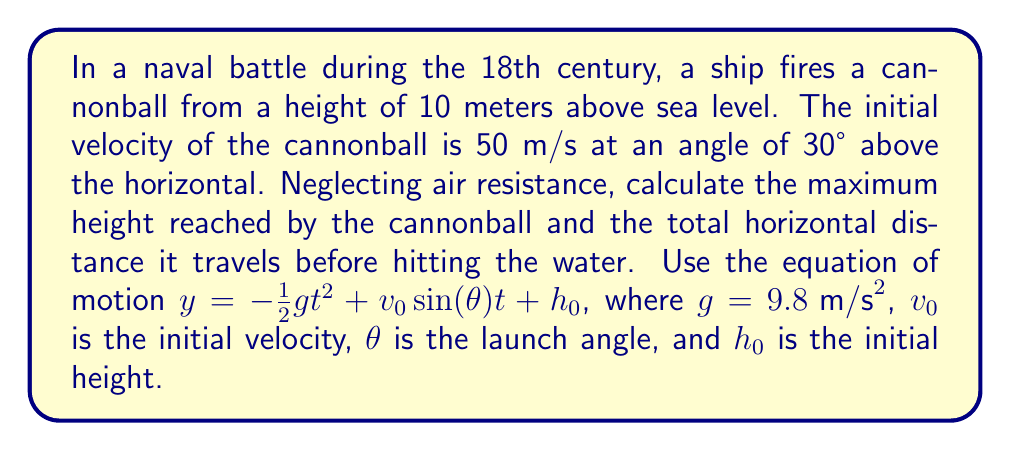Can you solve this math problem? Let's approach this step-by-step:

1) First, let's identify our known values:
   $v_0 = 50 \text{ m/s}$
   $\theta = 30°$
   $h_0 = 10 \text{ m}$
   $g = 9.8 \text{ m/s}^2$

2) To find the maximum height, we need to find when the vertical velocity is zero. The vertical component of velocity is given by:
   $v_y = v_0\sin(\theta) - gt$

3) Set this to zero and solve for t:
   $0 = 50\sin(30°) - 9.8t$
   $0 = 25 - 9.8t$
   $t = \frac{25}{9.8} \approx 2.55 \text{ s}$

4) Now we can plug this time into our equation of motion to find the maximum height:
   $y_{max} = -\frac{1}{2}(9.8)(2.55)^2 + 50\sin(30°)(2.55) + 10$
   $y_{max} \approx 41.8 \text{ m}$

5) To find the total horizontal distance, we need to find when y = 0 (sea level). We can use the quadratic formula to solve the equation:
   $0 = -\frac{1}{2}gt^2 + v_0\sin(\theta)t + h_0$

6) Substituting our values:
   $0 = -4.9t^2 + 25t + 10$

7) Using the quadratic formula $t = \frac{-b \pm \sqrt{b^2 - 4ac}}{2a}$:
   $t = \frac{-25 \pm \sqrt{25^2 - 4(-4.9)(10)}}{2(-4.9)}$
   $t \approx 5.77 \text{ s}$ (we take the positive root as time can't be negative)

8) The horizontal distance is given by $x = v_0\cos(\theta)t$:
   $x = 50\cos(30°)(5.77) \approx 249.8 \text{ m}$
Answer: Maximum height: 41.8 m; Horizontal distance: 249.8 m 